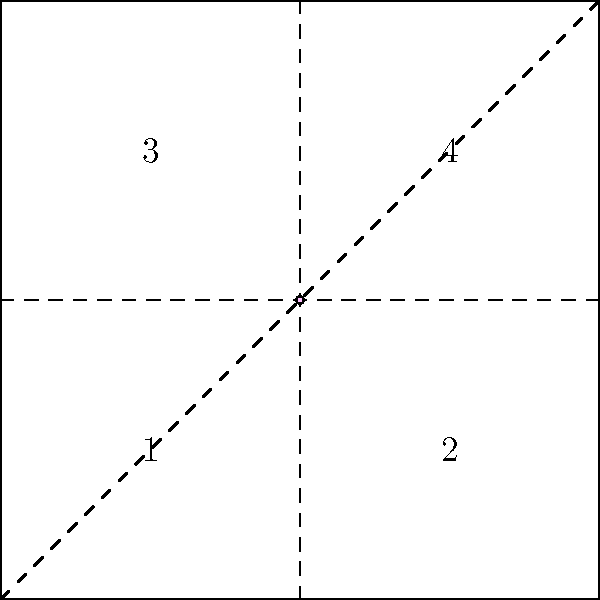If you mentally fold this origami pattern along the dashed lines to create a feminist icon, which numbered square will contain the pink dot in the final folded state? To solve this problem, we need to mentally follow the folding instructions:

1. The square is divided into four equal parts, numbered 1 to 4.
2. The pink dot is at the center of the square.
3. There are three fold lines: vertical, horizontal, and diagonal.
4. Folding along the vertical line (from left to right) would bring squares 1 and 3 over squares 2 and 4.
5. Folding along the horizontal line (from bottom to top) would bring squares 1 and 2 over squares 3 and 4.
6. Folding along the diagonal line (from bottom-left to top-right) would bring squares 1 and 4 together.
7. The final fold that creates the feminist icon is likely to be the diagonal fold, as it creates a triangle shape often associated with feminist symbolism.
8. When folded diagonally, the pink dot at the center would end up in square 1.

Therefore, after all the folds are made, the pink dot will be located in square 1.
Answer: 1 